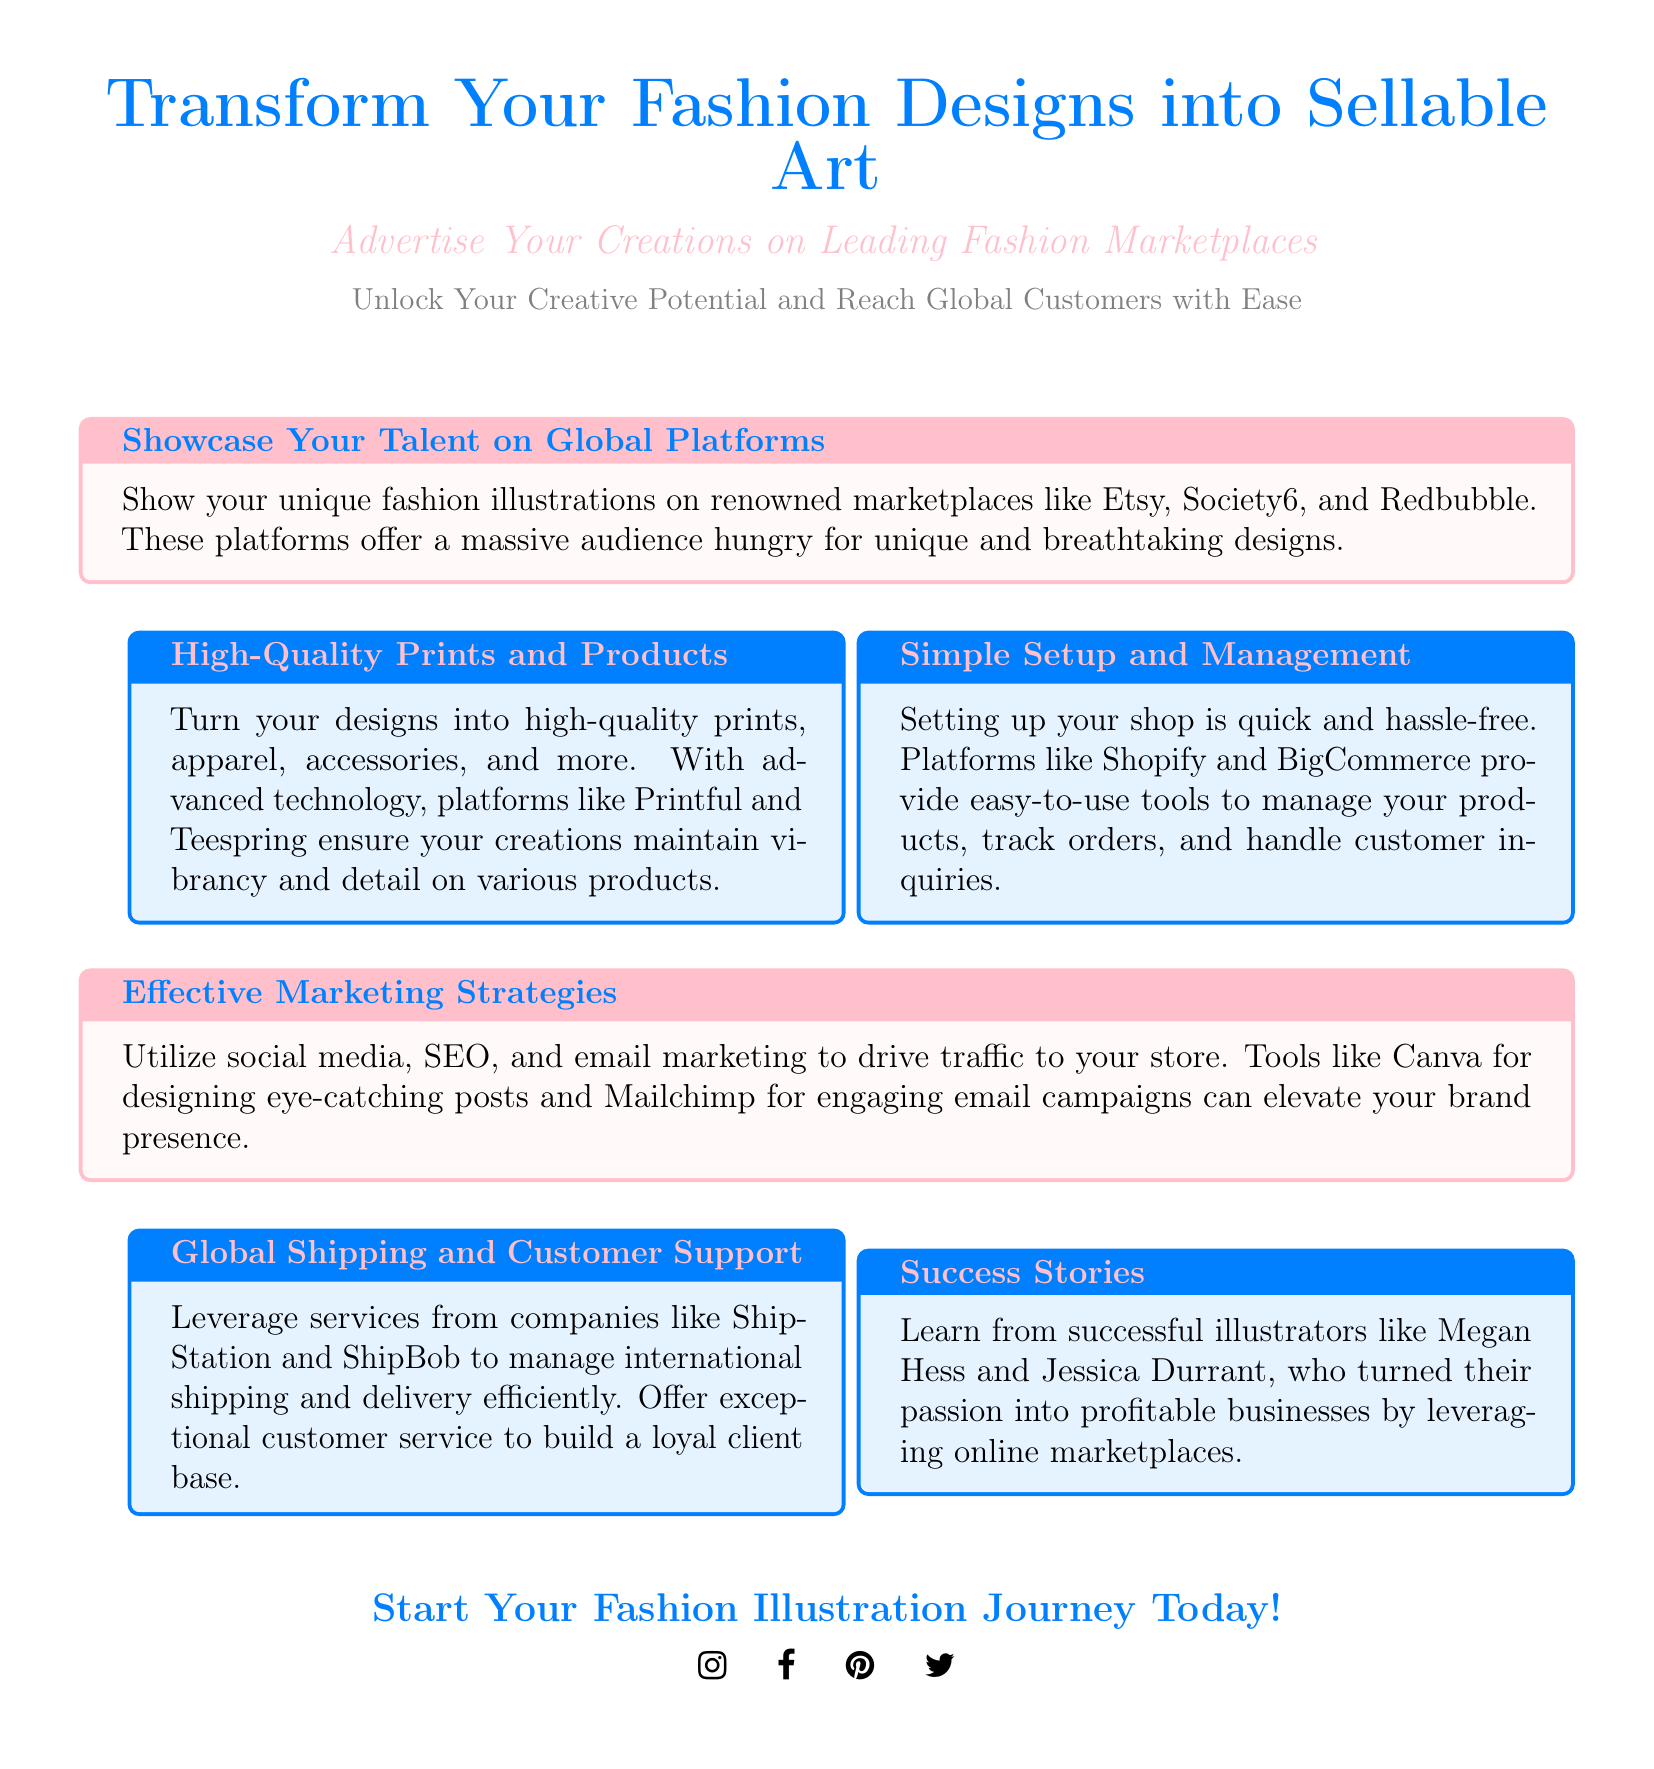What platforms can I showcase my fashion designs on? The document mentions renowned marketplaces such as Etsy, Society6, and Redbubble.
Answer: Etsy, Society6, Redbubble What is the primary focus of this advertisement? The ad promotes transforming fashion designs into sellable art by advertising on leading marketplaces.
Answer: Sellable art Which tools are recommended for effective marketing strategies? The document suggests using Canva for designing posts and Mailchimp for email campaigns to elevate brand presence.
Answer: Canva, Mailchimp Who are the successful illustrators mentioned in the document? The advertisement references Megan Hess and Jessica Durrant as examples of successful illustrators.
Answer: Megan Hess, Jessica Durrant How is shop setup described in the advertisement? The advertisement emphasizes that setting up a shop is quick and hassle-free on platforms like Shopify and BigCommerce.
Answer: Quick and hassle-free Which color is used to highlight the title in the document? The title color mentioned in the advertisement is fashion blue.
Answer: Fashion blue 